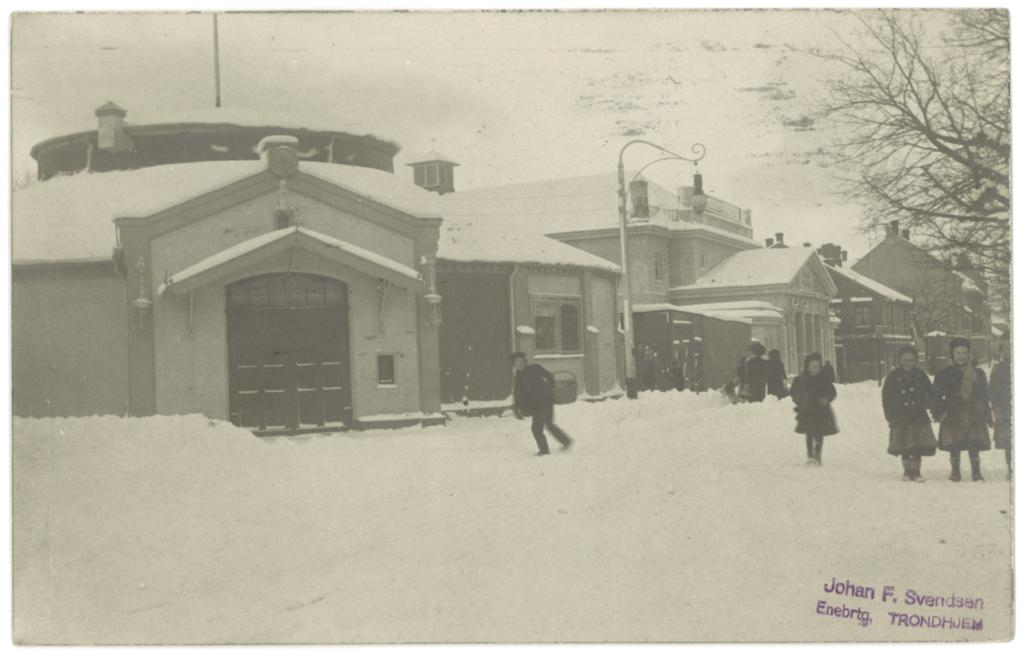What is the main subject of the image? The main subject of the image is a group of persons standing in the middle of the image. What is the condition of the ground in the image? The ground is covered in snow. What can be seen in the background of the image? There are buildings in the background of the image. What type of music is the band playing in the bedroom in the morning? There is no band or bedroom present in the image, and therefore no such activity can be observed. 